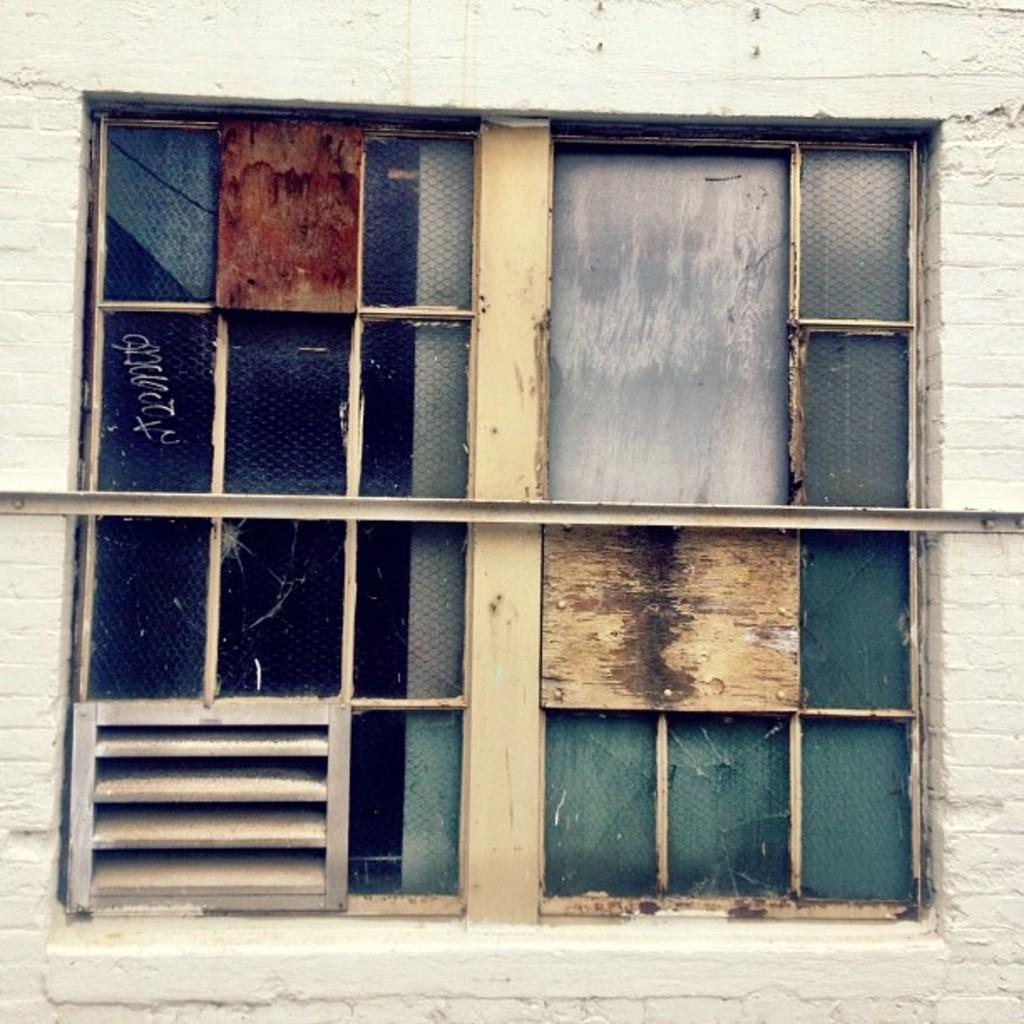What type of structure can be seen in the image? There is a wall in the image. Is there any opening in the wall visible in the image? Yes, there is a window in the image. What objects are present near the window? There are glasses visible in the image. What type of cup can be seen on the ground in the image? There is no cup present on the ground in the image. 